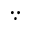<formula> <loc_0><loc_0><loc_500><loc_500>\because</formula> 